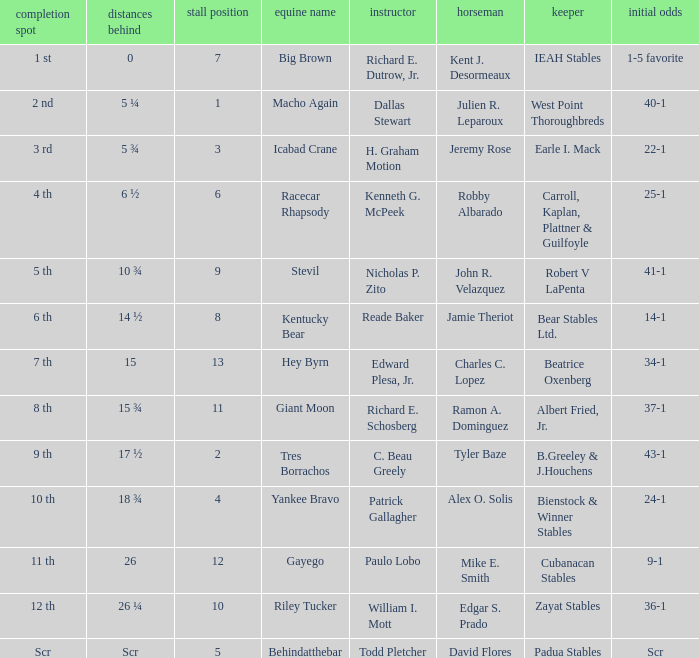What's the lengths behind of Jockey Ramon A. Dominguez? 15 ¾. 